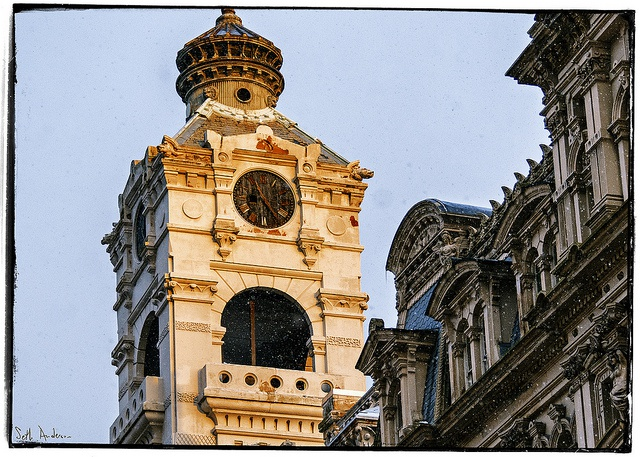Describe the objects in this image and their specific colors. I can see clock in white, black, maroon, and brown tones and clock in white, black, gray, purple, and darkblue tones in this image. 